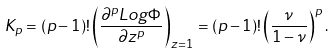<formula> <loc_0><loc_0><loc_500><loc_500>K _ { p } = ( p - 1 ) ! \left ( \frac { \partial ^ { p } L o g \Phi } { \partial z ^ { p } } \right ) _ { z = 1 } = ( p - 1 ) ! \left ( \frac { \nu } { 1 - \nu } \right ) ^ { p } .</formula> 